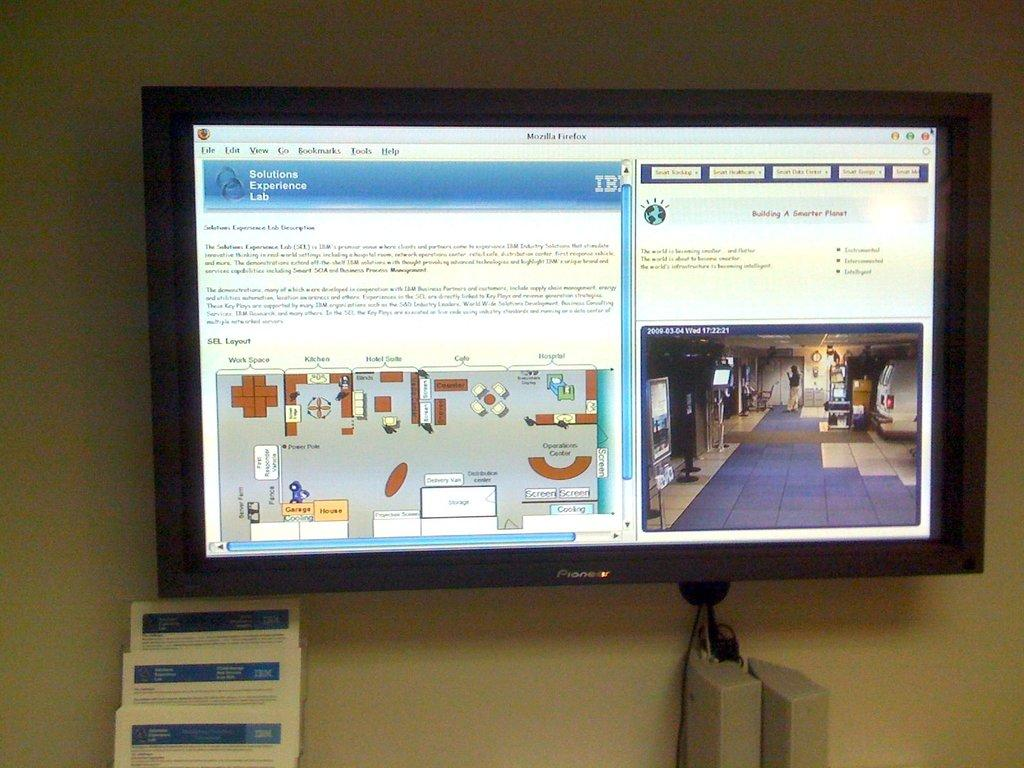<image>
Provide a brief description of the given image. A computer monitor shows a diagram of a room layout and an image of a room. 